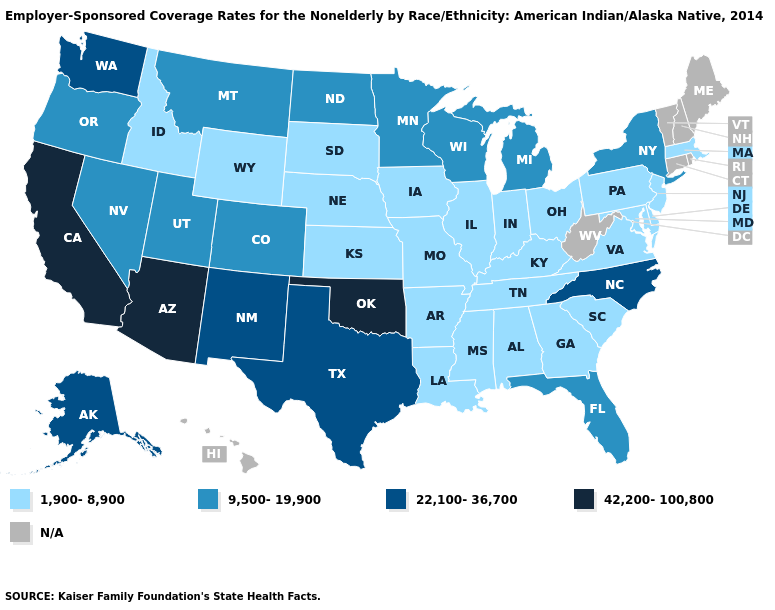Is the legend a continuous bar?
Give a very brief answer. No. Does California have the lowest value in the USA?
Be succinct. No. What is the value of Washington?
Write a very short answer. 22,100-36,700. Which states have the lowest value in the USA?
Quick response, please. Alabama, Arkansas, Delaware, Georgia, Idaho, Illinois, Indiana, Iowa, Kansas, Kentucky, Louisiana, Maryland, Massachusetts, Mississippi, Missouri, Nebraska, New Jersey, Ohio, Pennsylvania, South Carolina, South Dakota, Tennessee, Virginia, Wyoming. What is the highest value in the USA?
Be succinct. 42,200-100,800. Does the map have missing data?
Answer briefly. Yes. What is the value of Illinois?
Give a very brief answer. 1,900-8,900. What is the value of Kansas?
Be succinct. 1,900-8,900. What is the value of Oklahoma?
Write a very short answer. 42,200-100,800. Name the states that have a value in the range 22,100-36,700?
Short answer required. Alaska, New Mexico, North Carolina, Texas, Washington. Does Oregon have the highest value in the West?
Keep it brief. No. Name the states that have a value in the range 9,500-19,900?
Quick response, please. Colorado, Florida, Michigan, Minnesota, Montana, Nevada, New York, North Dakota, Oregon, Utah, Wisconsin. What is the highest value in the USA?
Keep it brief. 42,200-100,800. What is the value of Louisiana?
Be succinct. 1,900-8,900. 